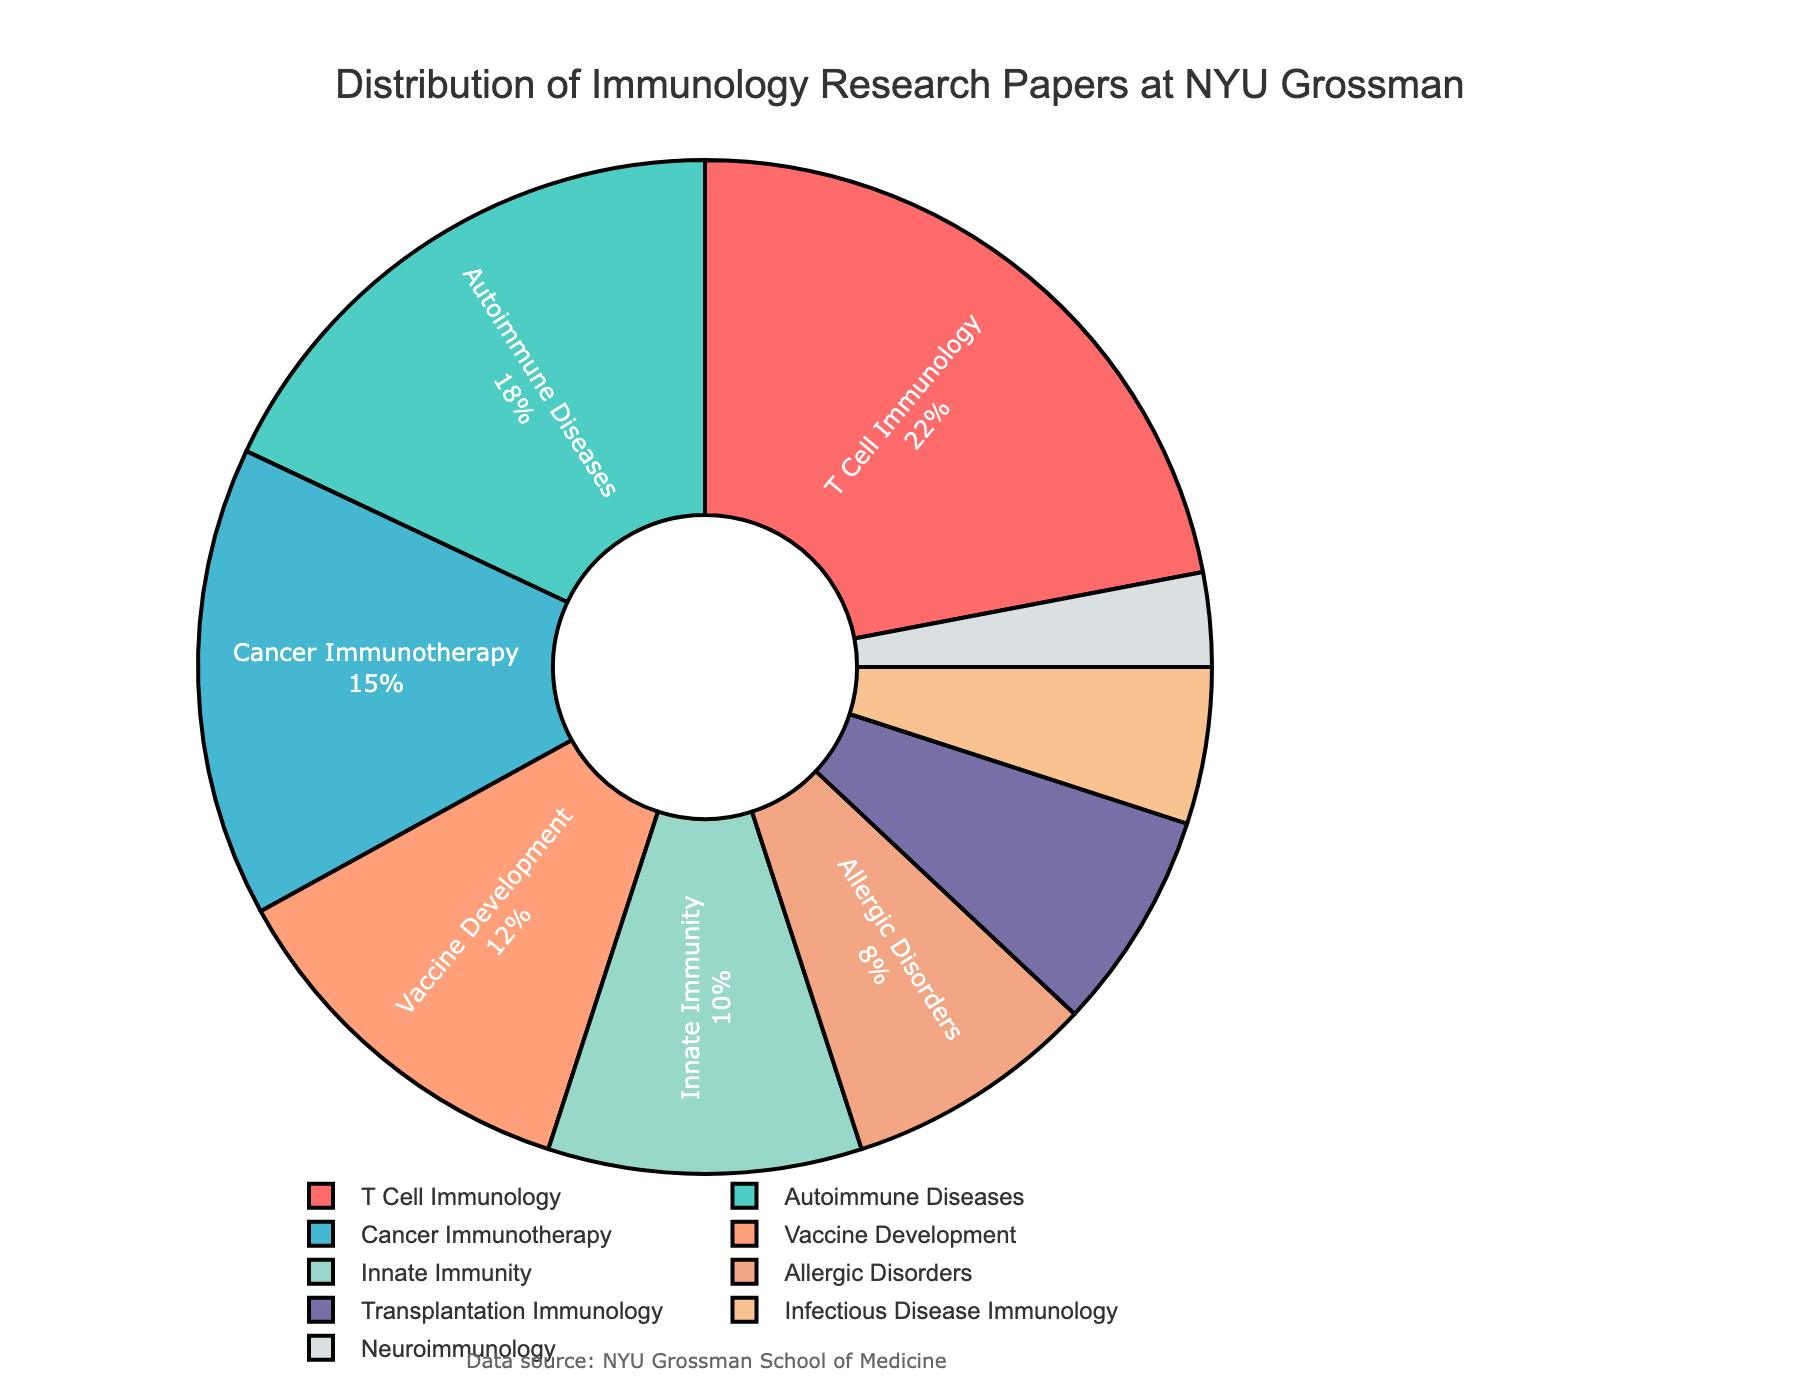What topic has the highest percentage of research papers published? The figure shows the distribution of research papers by topic in a pie chart format. T Cell Immunology occupies the largest segment of the pie chart.
Answer: T Cell Immunology Which two topics combined contribute to more than a third of the total research papers? Adding the percentages of T Cell Immunology (22%) and Autoimmune Diseases (18%) gives 40%, which is more than one-third of the total research papers.
Answer: T Cell Immunology and Autoimmune Diseases Compare the percentage of research papers in Cancer Immunotherapy to Vaccine Development. Which one is higher and by how much? The percentage for Cancer Immunotherapy is 15%, and for Vaccine Development, it is 12%. Subtracting these values, 15% - 12% = 3%, shows Cancer Immunotherapy is higher by 3%.
Answer: Cancer Immunotherapy by 3% Which topic is represented by the light green color in the pie chart? Examining the legend and the color palette used in the pie chart, the light green color corresponds to Innate Immunity.
Answer: Innate Immunity What is the total percentage of research papers published on topics related to disease immunology (Autoimmune Diseases, Infectious Disease Immunology, Cancer Immunotherapy, and Allergic Disorders)? Add the percentages of Autoimmune Diseases (18%), Infectious Disease Immunology (5%), Cancer Immunotherapy (15%), and Allergic Disorders (8%): 18% + 5% + 15% + 8% = 46%.
Answer: 46% Identify the topic associated with the smallest segment in the pie chart and give its percentage. The smallest segment in the pie chart is associated with Neuroimmunology, having a percentage of 3%.
Answer: Neuroimmunology, 3% How does the percentage of research papers in Transplantation Immunology compare to that in Allergic Disorders? Transplantation Immunology has 7% while Allergic Disorders has 8%. Subtracting these, 8% - 7% = 1%, shows Allergic Disorders has 1% more.
Answer: Allergic Disorders by 1% What is the total percentage for the top three topics combined? The top three topics by percentage are T Cell Immunology (22%), Autoimmune Diseases (18%), and Cancer Immunotherapy (15%). Adding these together, 22% + 18% + 15% = 55%.
Answer: 55% What percentage of research topics are not explicitly related to diseases (i.e., not Autoimmune Diseases, Cancer Immunotherapy, Allergic Disorders, Infectious Disease Immunology)? Calculate the total percentage of categories; T Cell Immunology (22%), Vaccine Development (12%), Innate Immunity (10%), Transplantation Immunology (7%), Neuroimmunology (3%) add up to 22% + 12% + 10% + 7% + 3% = 54%.
Answer: 54% 